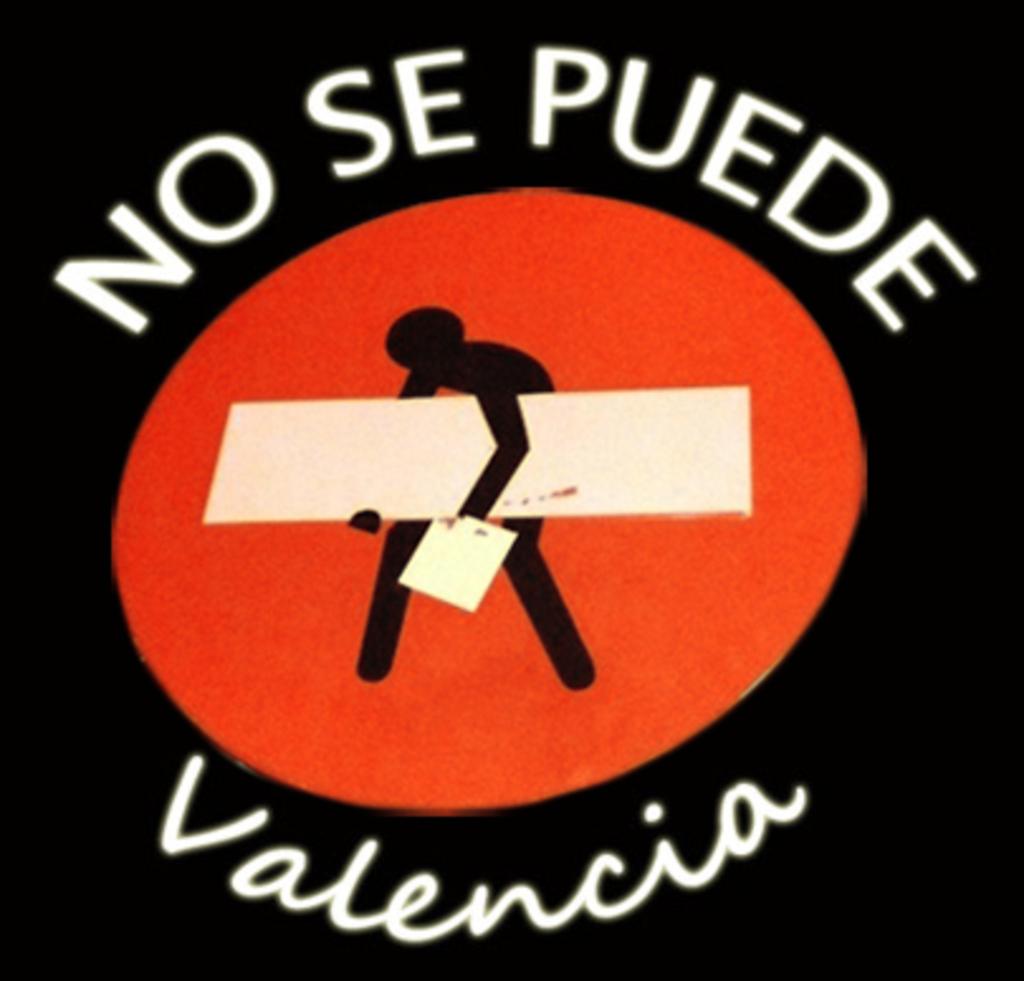What words are after no?
Your answer should be very brief. Se puede. What word is at the bottom?
Offer a terse response. Valencia. 